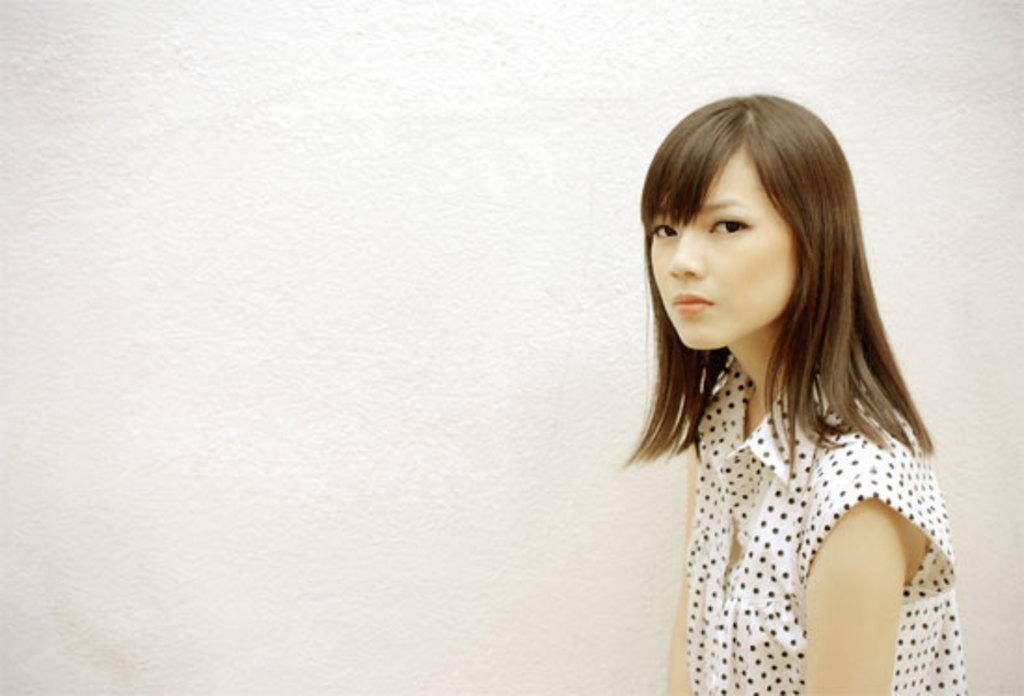What is the main subject of the image? There is a person in the image. What is the person wearing? The person is wearing a white and black color dress. What can be seen in the background of the image? The person is standing near a white wall. What type of hammer is the person holding in the image? A: There is no hammer present in the image; the person is simply standing near a white wall. 